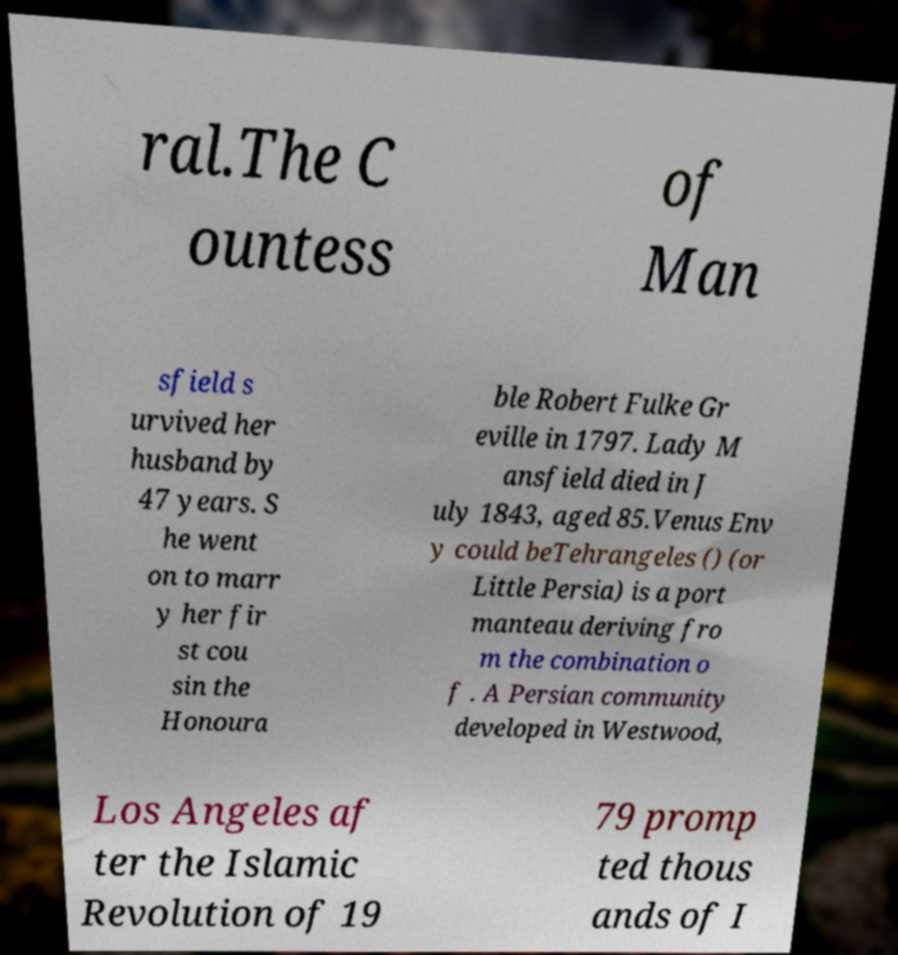Please identify and transcribe the text found in this image. ral.The C ountess of Man sfield s urvived her husband by 47 years. S he went on to marr y her fir st cou sin the Honoura ble Robert Fulke Gr eville in 1797. Lady M ansfield died in J uly 1843, aged 85.Venus Env y could beTehrangeles () (or Little Persia) is a port manteau deriving fro m the combination o f . A Persian community developed in Westwood, Los Angeles af ter the Islamic Revolution of 19 79 promp ted thous ands of I 